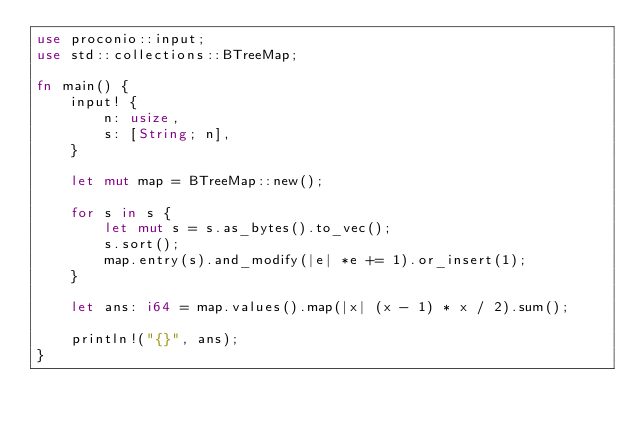Convert code to text. <code><loc_0><loc_0><loc_500><loc_500><_Rust_>use proconio::input;
use std::collections::BTreeMap;

fn main() {
    input! {
        n: usize,
        s: [String; n],
    }

    let mut map = BTreeMap::new();

    for s in s {
        let mut s = s.as_bytes().to_vec();
        s.sort();
        map.entry(s).and_modify(|e| *e += 1).or_insert(1);
    }

    let ans: i64 = map.values().map(|x| (x - 1) * x / 2).sum();

    println!("{}", ans);
}
</code> 